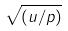<formula> <loc_0><loc_0><loc_500><loc_500>\sqrt { ( u / p ) }</formula> 